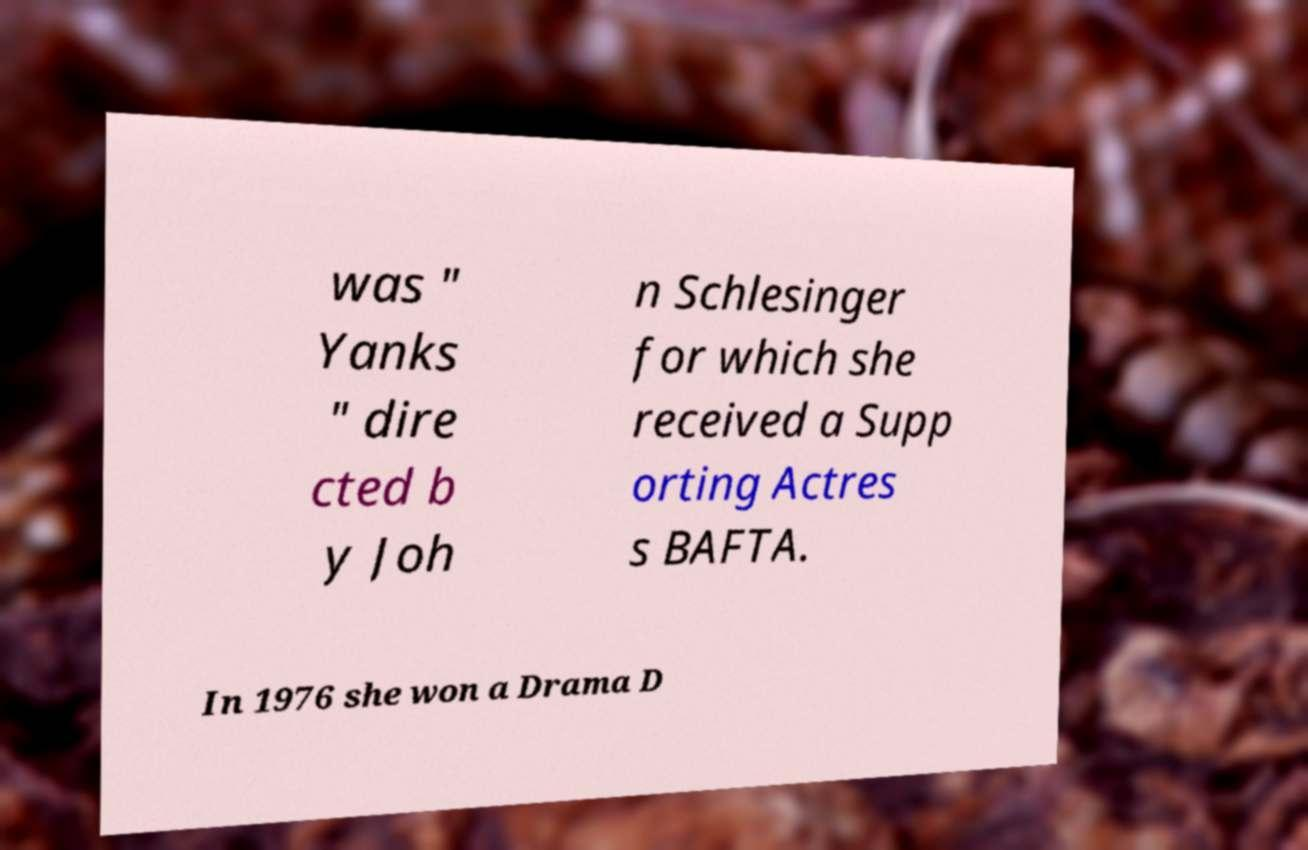Can you read and provide the text displayed in the image?This photo seems to have some interesting text. Can you extract and type it out for me? was " Yanks " dire cted b y Joh n Schlesinger for which she received a Supp orting Actres s BAFTA. In 1976 she won a Drama D 